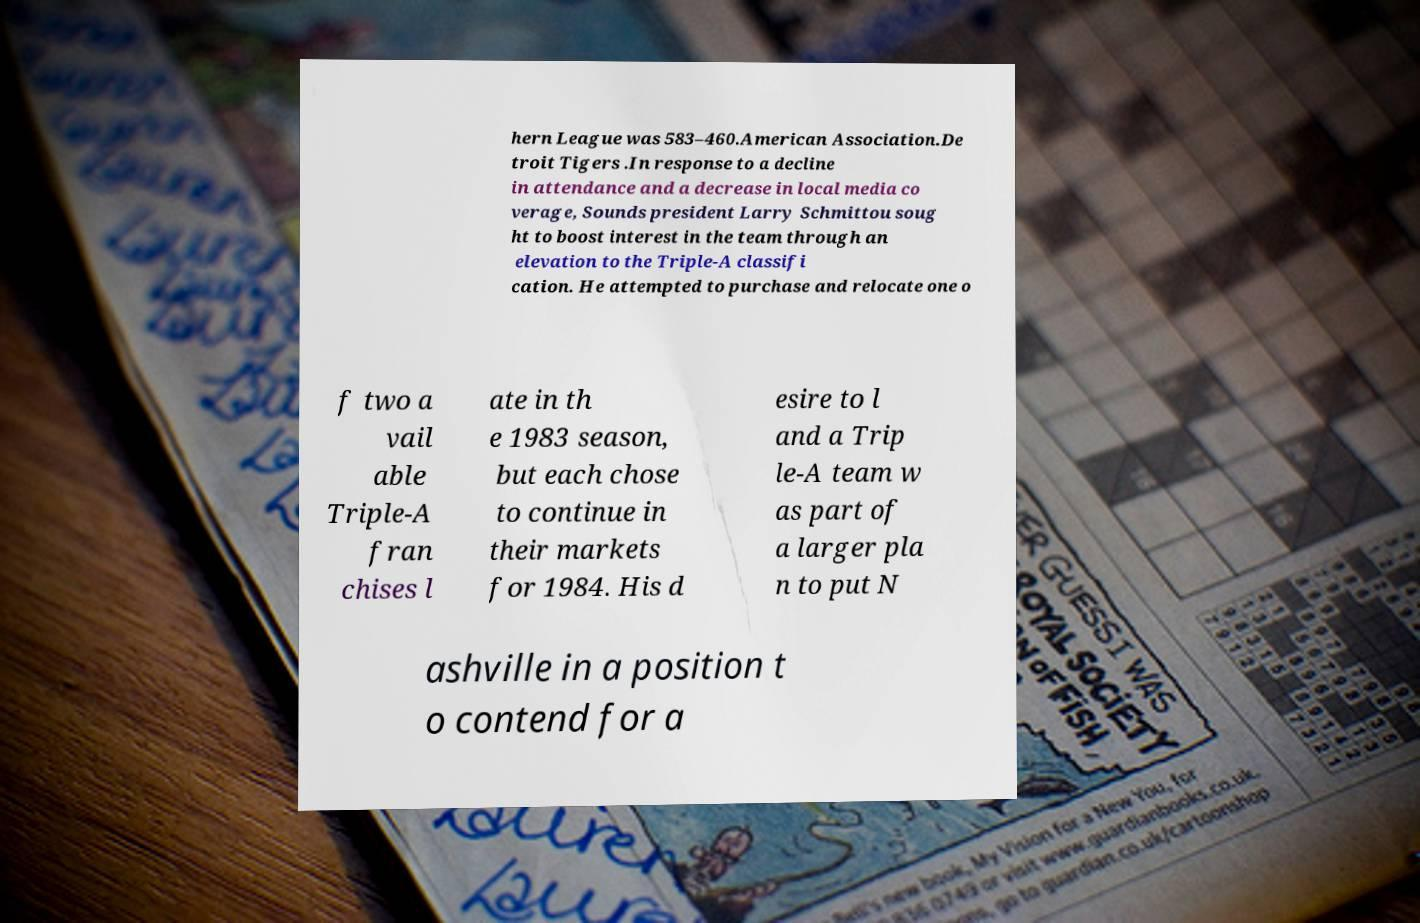I need the written content from this picture converted into text. Can you do that? hern League was 583–460.American Association.De troit Tigers .In response to a decline in attendance and a decrease in local media co verage, Sounds president Larry Schmittou soug ht to boost interest in the team through an elevation to the Triple-A classifi cation. He attempted to purchase and relocate one o f two a vail able Triple-A fran chises l ate in th e 1983 season, but each chose to continue in their markets for 1984. His d esire to l and a Trip le-A team w as part of a larger pla n to put N ashville in a position t o contend for a 